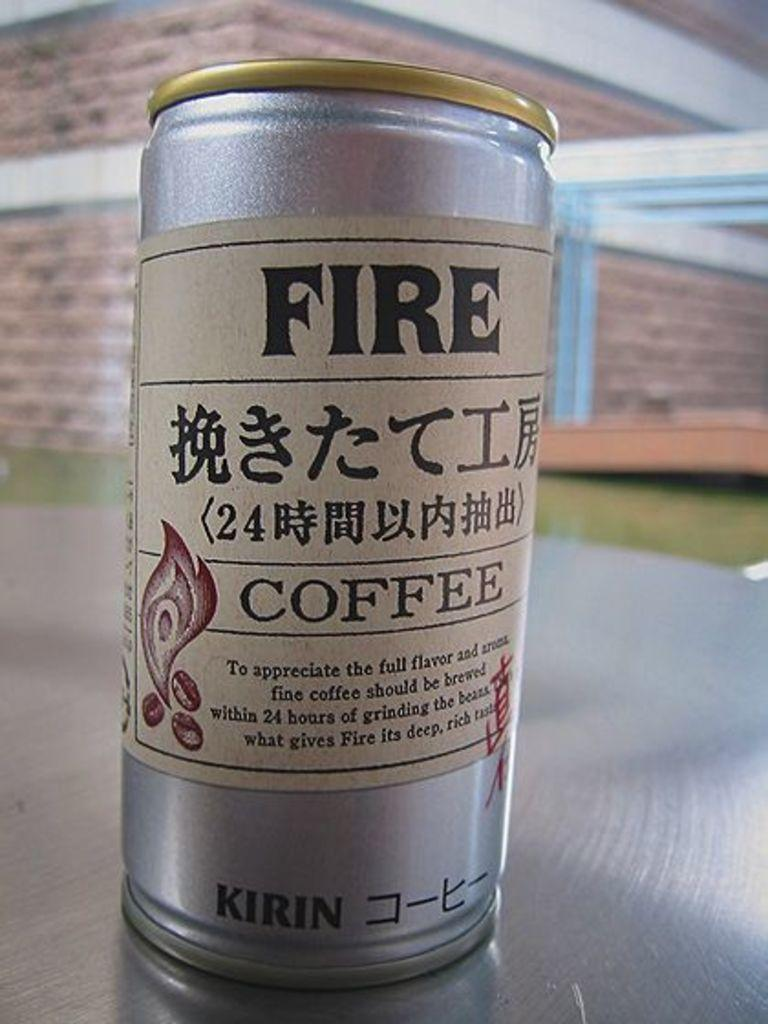<image>
Write a terse but informative summary of the picture. A can of Fire Coffee sits on a silver table. 